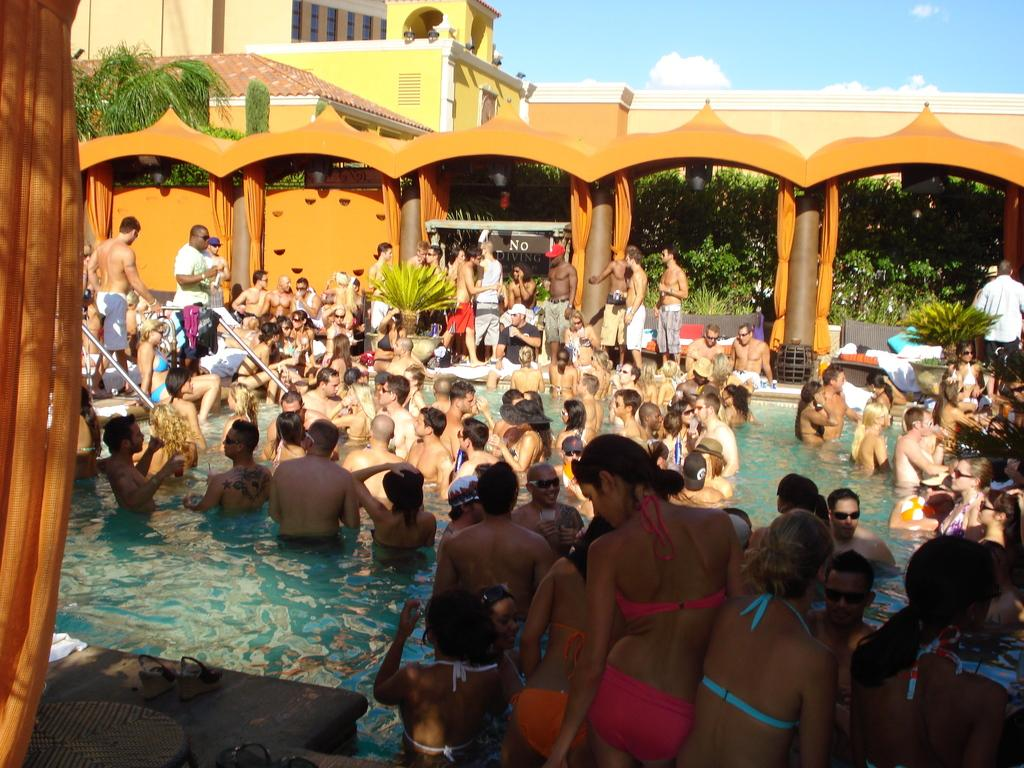What are the people in the image doing? The people in the image are in a swimming pool. What can be seen in the background of the image? There is a building and trees in the background of the image. How many girls are sitting on the airplane in the image? There is no airplane present in the image, so it is not possible to answer that question. 